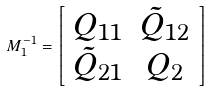Convert formula to latex. <formula><loc_0><loc_0><loc_500><loc_500>M _ { 1 } ^ { - 1 } = \left [ \begin{array} { c c } Q _ { 1 1 } & \tilde { Q } _ { 1 2 } \\ \tilde { Q } _ { 2 1 } & Q _ { 2 } \end{array} \right ]</formula> 